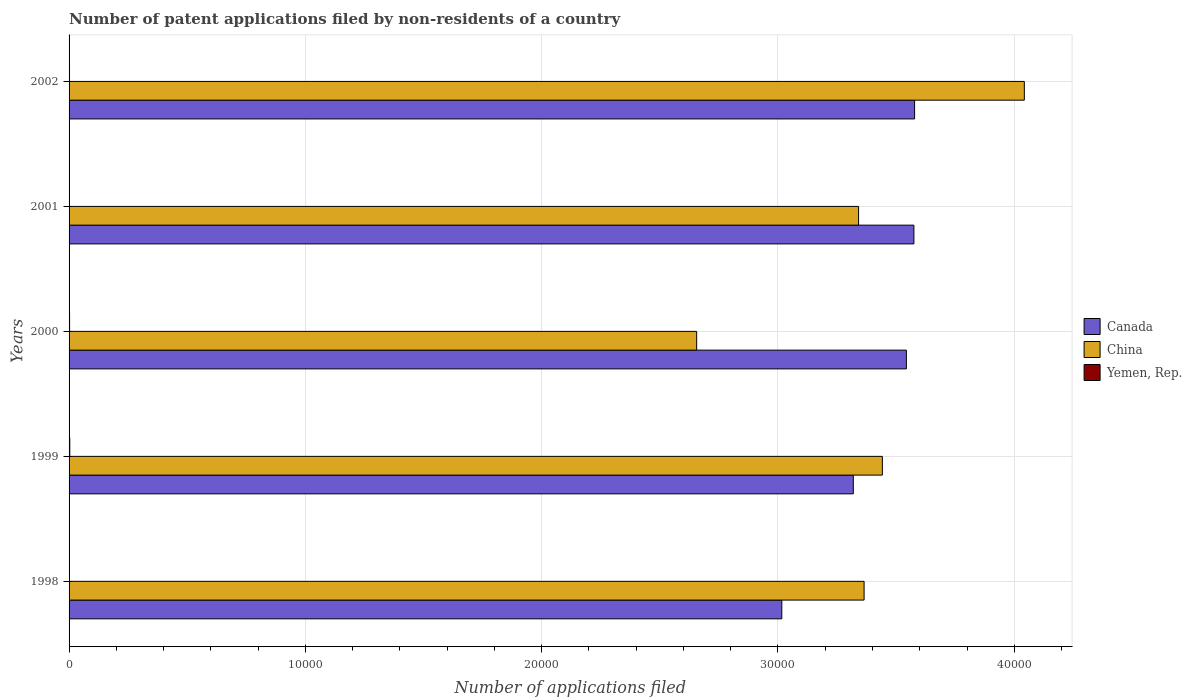How many different coloured bars are there?
Your answer should be compact. 3. How many groups of bars are there?
Offer a very short reply. 5. How many bars are there on the 4th tick from the top?
Your answer should be compact. 3. Across all years, what is the minimum number of applications filed in Canada?
Make the answer very short. 3.02e+04. In which year was the number of applications filed in Canada minimum?
Provide a succinct answer. 1998. What is the total number of applications filed in Yemen, Rep. in the graph?
Give a very brief answer. 105. What is the difference between the number of applications filed in China in 1998 and that in 2002?
Your response must be concise. -6781. What is the difference between the number of applications filed in Canada in 2000 and the number of applications filed in China in 2001?
Ensure brevity in your answer.  2023. What is the average number of applications filed in Canada per year?
Your response must be concise. 3.41e+04. In the year 1999, what is the difference between the number of applications filed in China and number of applications filed in Canada?
Provide a succinct answer. 1229. What is the ratio of the number of applications filed in Yemen, Rep. in 1998 to that in 2001?
Give a very brief answer. 0.89. Is the number of applications filed in China in 2000 less than that in 2001?
Keep it short and to the point. Yes. Is the difference between the number of applications filed in China in 1998 and 2001 greater than the difference between the number of applications filed in Canada in 1998 and 2001?
Your answer should be very brief. Yes. What is the difference between the highest and the lowest number of applications filed in China?
Provide a short and direct response. 1.39e+04. In how many years, is the number of applications filed in China greater than the average number of applications filed in China taken over all years?
Give a very brief answer. 2. Is the sum of the number of applications filed in Canada in 2000 and 2002 greater than the maximum number of applications filed in Yemen, Rep. across all years?
Provide a succinct answer. Yes. What does the 1st bar from the top in 1999 represents?
Your answer should be very brief. Yemen, Rep. What does the 3rd bar from the bottom in 2000 represents?
Offer a very short reply. Yemen, Rep. Is it the case that in every year, the sum of the number of applications filed in Canada and number of applications filed in Yemen, Rep. is greater than the number of applications filed in China?
Provide a succinct answer. No. How many years are there in the graph?
Make the answer very short. 5. What is the difference between two consecutive major ticks on the X-axis?
Provide a succinct answer. 10000. Are the values on the major ticks of X-axis written in scientific E-notation?
Offer a terse response. No. Where does the legend appear in the graph?
Keep it short and to the point. Center right. How many legend labels are there?
Offer a terse response. 3. How are the legend labels stacked?
Keep it short and to the point. Vertical. What is the title of the graph?
Your response must be concise. Number of patent applications filed by non-residents of a country. What is the label or title of the X-axis?
Your response must be concise. Number of applications filed. What is the Number of applications filed in Canada in 1998?
Provide a succinct answer. 3.02e+04. What is the Number of applications filed of China in 1998?
Your answer should be compact. 3.36e+04. What is the Number of applications filed of Yemen, Rep. in 1998?
Keep it short and to the point. 16. What is the Number of applications filed in Canada in 1999?
Offer a very short reply. 3.32e+04. What is the Number of applications filed in China in 1999?
Ensure brevity in your answer.  3.44e+04. What is the Number of applications filed in Canada in 2000?
Make the answer very short. 3.54e+04. What is the Number of applications filed of China in 2000?
Make the answer very short. 2.66e+04. What is the Number of applications filed of Canada in 2001?
Make the answer very short. 3.58e+04. What is the Number of applications filed of China in 2001?
Ensure brevity in your answer.  3.34e+04. What is the Number of applications filed of Canada in 2002?
Offer a terse response. 3.58e+04. What is the Number of applications filed of China in 2002?
Your answer should be very brief. 4.04e+04. Across all years, what is the maximum Number of applications filed of Canada?
Provide a succinct answer. 3.58e+04. Across all years, what is the maximum Number of applications filed of China?
Offer a terse response. 4.04e+04. Across all years, what is the maximum Number of applications filed in Yemen, Rep.?
Provide a succinct answer. 30. Across all years, what is the minimum Number of applications filed of Canada?
Give a very brief answer. 3.02e+04. Across all years, what is the minimum Number of applications filed in China?
Offer a terse response. 2.66e+04. Across all years, what is the minimum Number of applications filed in Yemen, Rep.?
Give a very brief answer. 16. What is the total Number of applications filed in Canada in the graph?
Offer a very short reply. 1.70e+05. What is the total Number of applications filed in China in the graph?
Make the answer very short. 1.68e+05. What is the total Number of applications filed in Yemen, Rep. in the graph?
Your response must be concise. 105. What is the difference between the Number of applications filed of Canada in 1998 and that in 1999?
Ensure brevity in your answer.  -3026. What is the difference between the Number of applications filed in China in 1998 and that in 1999?
Keep it short and to the point. -773. What is the difference between the Number of applications filed in Canada in 1998 and that in 2000?
Provide a short and direct response. -5272. What is the difference between the Number of applications filed of China in 1998 and that in 2000?
Keep it short and to the point. 7085. What is the difference between the Number of applications filed in Yemen, Rep. in 1998 and that in 2000?
Ensure brevity in your answer.  -6. What is the difference between the Number of applications filed in Canada in 1998 and that in 2001?
Your response must be concise. -5590. What is the difference between the Number of applications filed in China in 1998 and that in 2001?
Your answer should be very brief. 233. What is the difference between the Number of applications filed of Canada in 1998 and that in 2002?
Your answer should be compact. -5619. What is the difference between the Number of applications filed of China in 1998 and that in 2002?
Make the answer very short. -6781. What is the difference between the Number of applications filed in Canada in 1999 and that in 2000?
Offer a terse response. -2246. What is the difference between the Number of applications filed of China in 1999 and that in 2000?
Your response must be concise. 7858. What is the difference between the Number of applications filed in Yemen, Rep. in 1999 and that in 2000?
Your response must be concise. 8. What is the difference between the Number of applications filed in Canada in 1999 and that in 2001?
Ensure brevity in your answer.  -2564. What is the difference between the Number of applications filed of China in 1999 and that in 2001?
Offer a very short reply. 1006. What is the difference between the Number of applications filed of Canada in 1999 and that in 2002?
Offer a very short reply. -2593. What is the difference between the Number of applications filed of China in 1999 and that in 2002?
Keep it short and to the point. -6008. What is the difference between the Number of applications filed in Canada in 2000 and that in 2001?
Your answer should be very brief. -318. What is the difference between the Number of applications filed in China in 2000 and that in 2001?
Keep it short and to the point. -6852. What is the difference between the Number of applications filed of Canada in 2000 and that in 2002?
Offer a very short reply. -347. What is the difference between the Number of applications filed of China in 2000 and that in 2002?
Your response must be concise. -1.39e+04. What is the difference between the Number of applications filed of China in 2001 and that in 2002?
Ensure brevity in your answer.  -7014. What is the difference between the Number of applications filed in Canada in 1998 and the Number of applications filed in China in 1999?
Give a very brief answer. -4255. What is the difference between the Number of applications filed in Canada in 1998 and the Number of applications filed in Yemen, Rep. in 1999?
Keep it short and to the point. 3.01e+04. What is the difference between the Number of applications filed in China in 1998 and the Number of applications filed in Yemen, Rep. in 1999?
Your answer should be compact. 3.36e+04. What is the difference between the Number of applications filed in Canada in 1998 and the Number of applications filed in China in 2000?
Offer a very short reply. 3603. What is the difference between the Number of applications filed in Canada in 1998 and the Number of applications filed in Yemen, Rep. in 2000?
Offer a very short reply. 3.01e+04. What is the difference between the Number of applications filed in China in 1998 and the Number of applications filed in Yemen, Rep. in 2000?
Provide a short and direct response. 3.36e+04. What is the difference between the Number of applications filed in Canada in 1998 and the Number of applications filed in China in 2001?
Your response must be concise. -3249. What is the difference between the Number of applications filed in Canada in 1998 and the Number of applications filed in Yemen, Rep. in 2001?
Ensure brevity in your answer.  3.01e+04. What is the difference between the Number of applications filed of China in 1998 and the Number of applications filed of Yemen, Rep. in 2001?
Your answer should be very brief. 3.36e+04. What is the difference between the Number of applications filed in Canada in 1998 and the Number of applications filed in China in 2002?
Give a very brief answer. -1.03e+04. What is the difference between the Number of applications filed of Canada in 1998 and the Number of applications filed of Yemen, Rep. in 2002?
Ensure brevity in your answer.  3.01e+04. What is the difference between the Number of applications filed of China in 1998 and the Number of applications filed of Yemen, Rep. in 2002?
Provide a short and direct response. 3.36e+04. What is the difference between the Number of applications filed in Canada in 1999 and the Number of applications filed in China in 2000?
Provide a short and direct response. 6629. What is the difference between the Number of applications filed in Canada in 1999 and the Number of applications filed in Yemen, Rep. in 2000?
Offer a terse response. 3.32e+04. What is the difference between the Number of applications filed of China in 1999 and the Number of applications filed of Yemen, Rep. in 2000?
Give a very brief answer. 3.44e+04. What is the difference between the Number of applications filed of Canada in 1999 and the Number of applications filed of China in 2001?
Your response must be concise. -223. What is the difference between the Number of applications filed of Canada in 1999 and the Number of applications filed of Yemen, Rep. in 2001?
Provide a succinct answer. 3.32e+04. What is the difference between the Number of applications filed in China in 1999 and the Number of applications filed in Yemen, Rep. in 2001?
Keep it short and to the point. 3.44e+04. What is the difference between the Number of applications filed of Canada in 1999 and the Number of applications filed of China in 2002?
Give a very brief answer. -7237. What is the difference between the Number of applications filed of Canada in 1999 and the Number of applications filed of Yemen, Rep. in 2002?
Provide a short and direct response. 3.32e+04. What is the difference between the Number of applications filed of China in 1999 and the Number of applications filed of Yemen, Rep. in 2002?
Make the answer very short. 3.44e+04. What is the difference between the Number of applications filed of Canada in 2000 and the Number of applications filed of China in 2001?
Provide a short and direct response. 2023. What is the difference between the Number of applications filed of Canada in 2000 and the Number of applications filed of Yemen, Rep. in 2001?
Provide a succinct answer. 3.54e+04. What is the difference between the Number of applications filed in China in 2000 and the Number of applications filed in Yemen, Rep. in 2001?
Give a very brief answer. 2.65e+04. What is the difference between the Number of applications filed of Canada in 2000 and the Number of applications filed of China in 2002?
Provide a short and direct response. -4991. What is the difference between the Number of applications filed of Canada in 2000 and the Number of applications filed of Yemen, Rep. in 2002?
Your answer should be very brief. 3.54e+04. What is the difference between the Number of applications filed in China in 2000 and the Number of applications filed in Yemen, Rep. in 2002?
Provide a succinct answer. 2.65e+04. What is the difference between the Number of applications filed in Canada in 2001 and the Number of applications filed in China in 2002?
Your response must be concise. -4673. What is the difference between the Number of applications filed of Canada in 2001 and the Number of applications filed of Yemen, Rep. in 2002?
Give a very brief answer. 3.57e+04. What is the difference between the Number of applications filed of China in 2001 and the Number of applications filed of Yemen, Rep. in 2002?
Keep it short and to the point. 3.34e+04. What is the average Number of applications filed in Canada per year?
Your answer should be very brief. 3.41e+04. What is the average Number of applications filed of China per year?
Ensure brevity in your answer.  3.37e+04. In the year 1998, what is the difference between the Number of applications filed of Canada and Number of applications filed of China?
Offer a terse response. -3482. In the year 1998, what is the difference between the Number of applications filed in Canada and Number of applications filed in Yemen, Rep.?
Offer a very short reply. 3.01e+04. In the year 1998, what is the difference between the Number of applications filed in China and Number of applications filed in Yemen, Rep.?
Your answer should be very brief. 3.36e+04. In the year 1999, what is the difference between the Number of applications filed in Canada and Number of applications filed in China?
Give a very brief answer. -1229. In the year 1999, what is the difference between the Number of applications filed in Canada and Number of applications filed in Yemen, Rep.?
Keep it short and to the point. 3.32e+04. In the year 1999, what is the difference between the Number of applications filed in China and Number of applications filed in Yemen, Rep.?
Give a very brief answer. 3.44e+04. In the year 2000, what is the difference between the Number of applications filed in Canada and Number of applications filed in China?
Keep it short and to the point. 8875. In the year 2000, what is the difference between the Number of applications filed in Canada and Number of applications filed in Yemen, Rep.?
Your response must be concise. 3.54e+04. In the year 2000, what is the difference between the Number of applications filed of China and Number of applications filed of Yemen, Rep.?
Offer a very short reply. 2.65e+04. In the year 2001, what is the difference between the Number of applications filed in Canada and Number of applications filed in China?
Your response must be concise. 2341. In the year 2001, what is the difference between the Number of applications filed in Canada and Number of applications filed in Yemen, Rep.?
Provide a short and direct response. 3.57e+04. In the year 2001, what is the difference between the Number of applications filed in China and Number of applications filed in Yemen, Rep.?
Ensure brevity in your answer.  3.34e+04. In the year 2002, what is the difference between the Number of applications filed of Canada and Number of applications filed of China?
Keep it short and to the point. -4644. In the year 2002, what is the difference between the Number of applications filed in Canada and Number of applications filed in Yemen, Rep.?
Offer a very short reply. 3.58e+04. In the year 2002, what is the difference between the Number of applications filed of China and Number of applications filed of Yemen, Rep.?
Provide a short and direct response. 4.04e+04. What is the ratio of the Number of applications filed in Canada in 1998 to that in 1999?
Your answer should be compact. 0.91. What is the ratio of the Number of applications filed of China in 1998 to that in 1999?
Your answer should be very brief. 0.98. What is the ratio of the Number of applications filed of Yemen, Rep. in 1998 to that in 1999?
Your answer should be very brief. 0.53. What is the ratio of the Number of applications filed of Canada in 1998 to that in 2000?
Offer a terse response. 0.85. What is the ratio of the Number of applications filed of China in 1998 to that in 2000?
Give a very brief answer. 1.27. What is the ratio of the Number of applications filed of Yemen, Rep. in 1998 to that in 2000?
Your answer should be very brief. 0.73. What is the ratio of the Number of applications filed of Canada in 1998 to that in 2001?
Your answer should be compact. 0.84. What is the ratio of the Number of applications filed in China in 1998 to that in 2001?
Your answer should be compact. 1.01. What is the ratio of the Number of applications filed of Canada in 1998 to that in 2002?
Give a very brief answer. 0.84. What is the ratio of the Number of applications filed of China in 1998 to that in 2002?
Offer a terse response. 0.83. What is the ratio of the Number of applications filed in Yemen, Rep. in 1998 to that in 2002?
Keep it short and to the point. 0.84. What is the ratio of the Number of applications filed in Canada in 1999 to that in 2000?
Your answer should be compact. 0.94. What is the ratio of the Number of applications filed of China in 1999 to that in 2000?
Your answer should be very brief. 1.3. What is the ratio of the Number of applications filed in Yemen, Rep. in 1999 to that in 2000?
Provide a succinct answer. 1.36. What is the ratio of the Number of applications filed in Canada in 1999 to that in 2001?
Provide a short and direct response. 0.93. What is the ratio of the Number of applications filed of China in 1999 to that in 2001?
Make the answer very short. 1.03. What is the ratio of the Number of applications filed of Canada in 1999 to that in 2002?
Your response must be concise. 0.93. What is the ratio of the Number of applications filed of China in 1999 to that in 2002?
Provide a succinct answer. 0.85. What is the ratio of the Number of applications filed of Yemen, Rep. in 1999 to that in 2002?
Make the answer very short. 1.58. What is the ratio of the Number of applications filed of Canada in 2000 to that in 2001?
Ensure brevity in your answer.  0.99. What is the ratio of the Number of applications filed of China in 2000 to that in 2001?
Keep it short and to the point. 0.79. What is the ratio of the Number of applications filed of Yemen, Rep. in 2000 to that in 2001?
Give a very brief answer. 1.22. What is the ratio of the Number of applications filed in Canada in 2000 to that in 2002?
Provide a short and direct response. 0.99. What is the ratio of the Number of applications filed in China in 2000 to that in 2002?
Provide a short and direct response. 0.66. What is the ratio of the Number of applications filed in Yemen, Rep. in 2000 to that in 2002?
Your answer should be very brief. 1.16. What is the ratio of the Number of applications filed of China in 2001 to that in 2002?
Ensure brevity in your answer.  0.83. What is the ratio of the Number of applications filed of Yemen, Rep. in 2001 to that in 2002?
Ensure brevity in your answer.  0.95. What is the difference between the highest and the second highest Number of applications filed of Canada?
Provide a short and direct response. 29. What is the difference between the highest and the second highest Number of applications filed in China?
Give a very brief answer. 6008. What is the difference between the highest and the lowest Number of applications filed in Canada?
Your response must be concise. 5619. What is the difference between the highest and the lowest Number of applications filed of China?
Your answer should be very brief. 1.39e+04. 